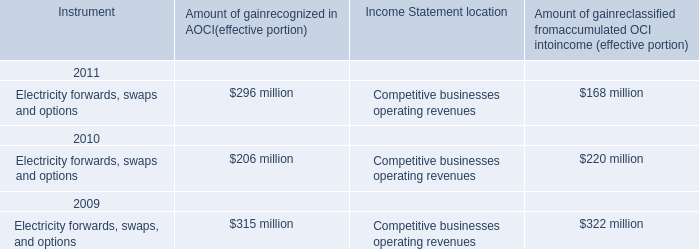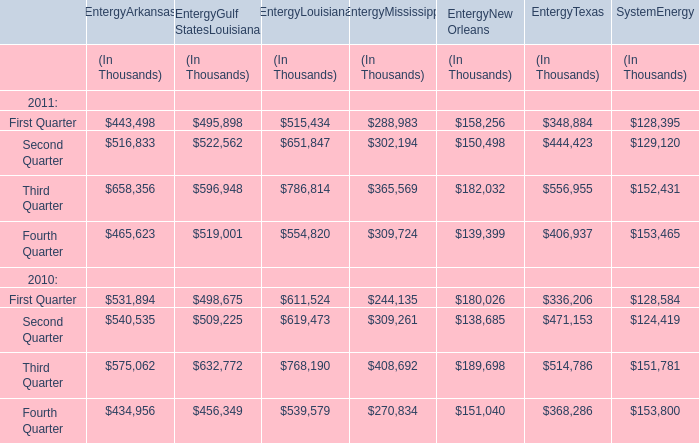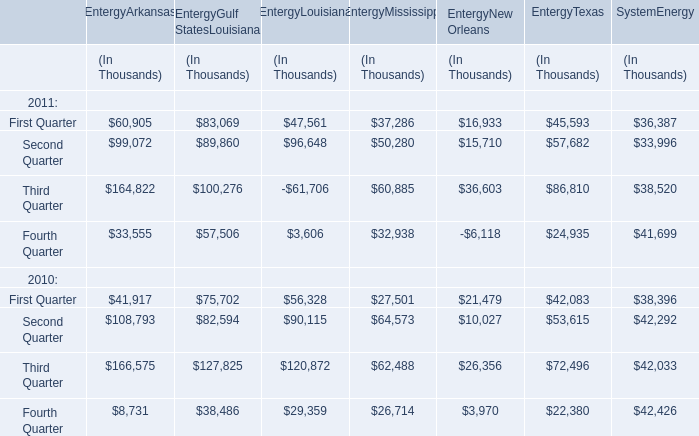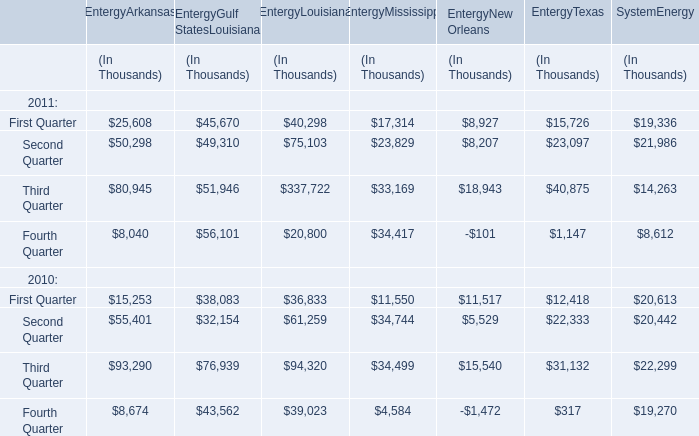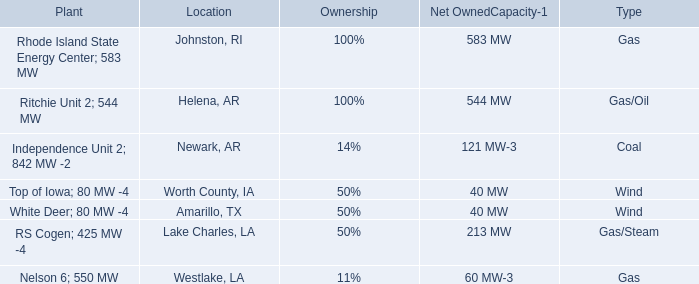What's the sum of all elements for EntergyArkansas that are greater than 500000 in 2011? (in thousand) 
Computations: (516833 + 658356)
Answer: 1175189.0. 